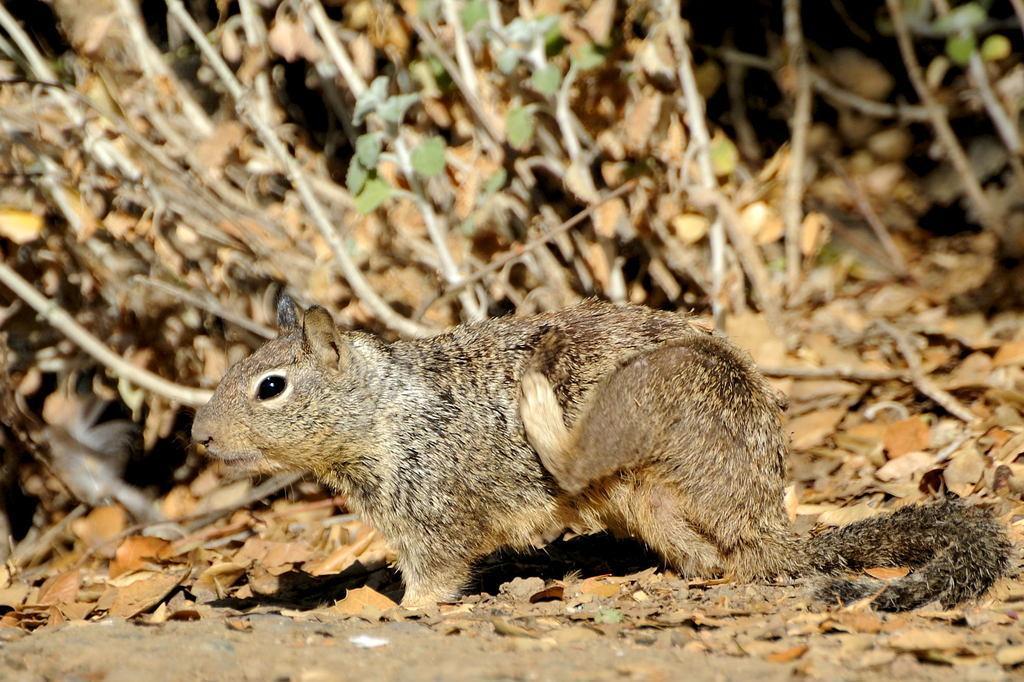Describe this image in one or two sentences. In this picture I can see a squirrel on the ground and I can see few dry leaves and few plants. 